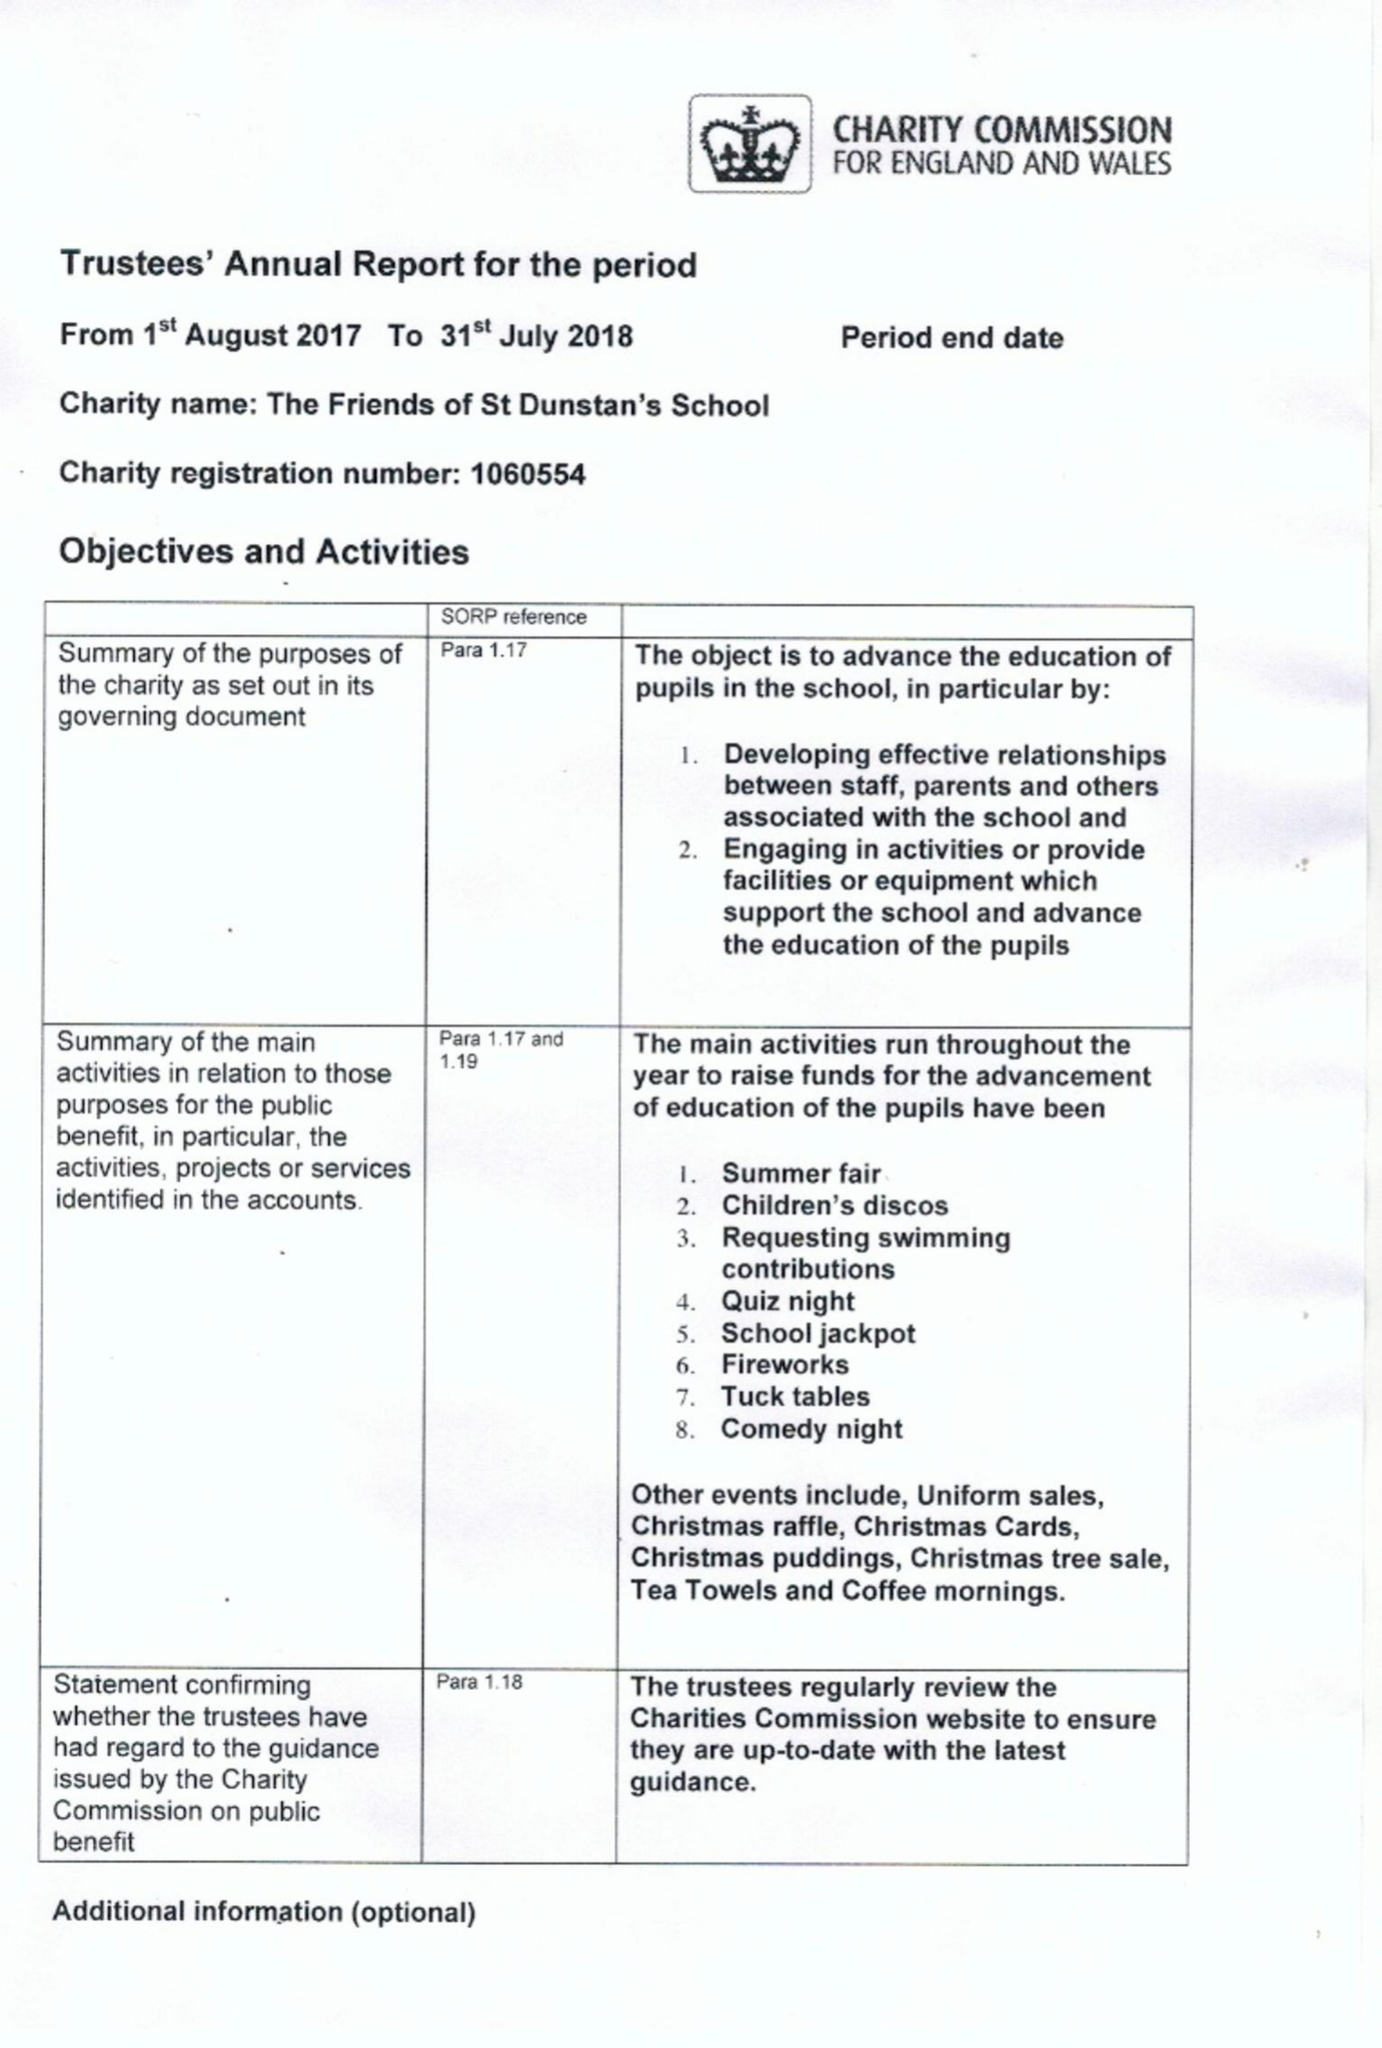What is the value for the address__post_town?
Answer the question using a single word or phrase. WOKING 